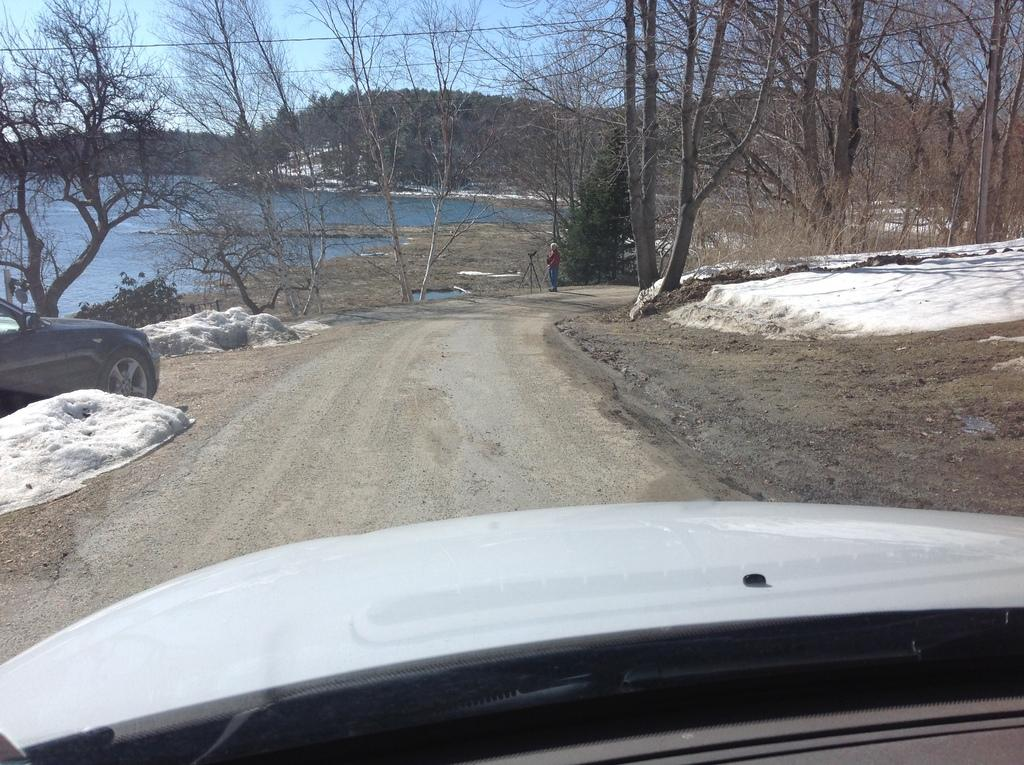What type of natural environment is depicted in the image? There are trees and sand in the image, suggesting a beach or coastal area. What else can be seen in the image besides the natural environment? There are vehicles and water visible in the image. Can you describe the person in the image? There is a person standing in the image. What might the person be doing in the image? It is not clear from the image what the person is doing, but they are standing near the water and vehicles. What type of cough medicine is visible in the image? There is no cough medicine present in the image. What force is being applied to the trees in the image? There is no force being applied to the trees in the image; they are stationary. 